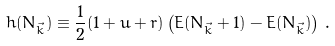<formula> <loc_0><loc_0><loc_500><loc_500>h ( N _ { \vec { k } } ) \equiv \frac { 1 } { 2 } ( 1 + u + r ) \left ( E ( N _ { \vec { k } } + 1 ) - E ( N _ { \vec { k } } ) \right ) \, .</formula> 